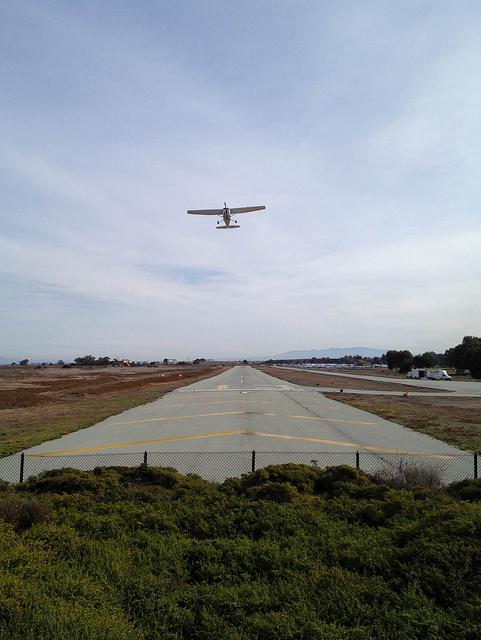Is the sun out and shining?
Concise answer only. Yes. What defense is on top of the fence?
Quick response, please. Barbed wire. Why are there yellow markings on the runway?
Give a very brief answer. To assist with takeoff. What is in the air?
Quick response, please. Plane. What is the land formation in the background of the picture?
Quick response, please. Runway. Where is the shrubbery?
Write a very short answer. Runway. What is this a picture of?
Short answer required. Runway. What mode of transport is shown?
Write a very short answer. Airplane. What is at the end of the runway?
Give a very brief answer. Trees. Is the plane taking off or landing?
Answer briefly. Taking off. What is the person riding on?
Be succinct. Plane. Can a body of water be seen in this picture?
Write a very short answer. No. Does this glider get towed?
Be succinct. No. What color is the ground?
Write a very short answer. Gray. What type of transportation do you see?
Short answer required. Plane. What is in the sky?
Answer briefly. Plane. What is ahead?
Concise answer only. Plane. What color are the stripes?
Keep it brief. Yellow. Is this a natural wildlife preserve?
Keep it brief. No. How many lanes are on the road?
Concise answer only. 1. Is this a good place for lunch?
Concise answer only. No. What are the people flying?
Write a very short answer. Airplane. Is this plane still being flown?
Answer briefly. Yes. How many planes are there?
Give a very brief answer. 1. Is this a country setting?
Give a very brief answer. Yes. 